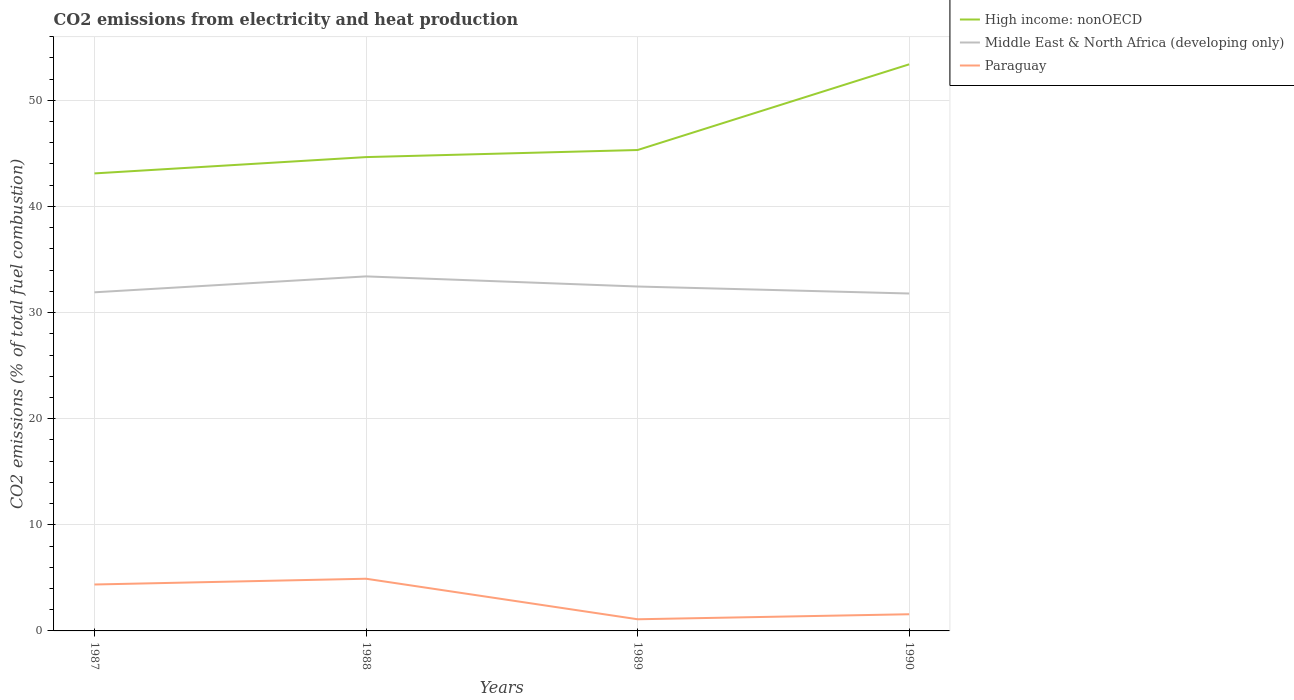How many different coloured lines are there?
Your response must be concise. 3. Across all years, what is the maximum amount of CO2 emitted in Paraguay?
Give a very brief answer. 1.1. What is the total amount of CO2 emitted in High income: nonOECD in the graph?
Your answer should be compact. -8.07. What is the difference between the highest and the second highest amount of CO2 emitted in Middle East & North Africa (developing only)?
Make the answer very short. 1.61. What is the difference between the highest and the lowest amount of CO2 emitted in Middle East & North Africa (developing only)?
Keep it short and to the point. 2. How many years are there in the graph?
Your answer should be very brief. 4. What is the difference between two consecutive major ticks on the Y-axis?
Offer a very short reply. 10. Does the graph contain any zero values?
Keep it short and to the point. No. Does the graph contain grids?
Make the answer very short. Yes. Where does the legend appear in the graph?
Ensure brevity in your answer.  Top right. What is the title of the graph?
Make the answer very short. CO2 emissions from electricity and heat production. What is the label or title of the Y-axis?
Ensure brevity in your answer.  CO2 emissions (% of total fuel combustion). What is the CO2 emissions (% of total fuel combustion) in High income: nonOECD in 1987?
Provide a succinct answer. 43.11. What is the CO2 emissions (% of total fuel combustion) in Middle East & North Africa (developing only) in 1987?
Ensure brevity in your answer.  31.91. What is the CO2 emissions (% of total fuel combustion) in Paraguay in 1987?
Offer a terse response. 4.38. What is the CO2 emissions (% of total fuel combustion) in High income: nonOECD in 1988?
Provide a short and direct response. 44.65. What is the CO2 emissions (% of total fuel combustion) in Middle East & North Africa (developing only) in 1988?
Keep it short and to the point. 33.41. What is the CO2 emissions (% of total fuel combustion) of Paraguay in 1988?
Your answer should be compact. 4.92. What is the CO2 emissions (% of total fuel combustion) in High income: nonOECD in 1989?
Your response must be concise. 45.32. What is the CO2 emissions (% of total fuel combustion) in Middle East & North Africa (developing only) in 1989?
Make the answer very short. 32.45. What is the CO2 emissions (% of total fuel combustion) in Paraguay in 1989?
Your response must be concise. 1.1. What is the CO2 emissions (% of total fuel combustion) of High income: nonOECD in 1990?
Give a very brief answer. 53.39. What is the CO2 emissions (% of total fuel combustion) in Middle East & North Africa (developing only) in 1990?
Your response must be concise. 31.8. What is the CO2 emissions (% of total fuel combustion) of Paraguay in 1990?
Provide a succinct answer. 1.57. Across all years, what is the maximum CO2 emissions (% of total fuel combustion) in High income: nonOECD?
Your answer should be compact. 53.39. Across all years, what is the maximum CO2 emissions (% of total fuel combustion) of Middle East & North Africa (developing only)?
Keep it short and to the point. 33.41. Across all years, what is the maximum CO2 emissions (% of total fuel combustion) in Paraguay?
Provide a short and direct response. 4.92. Across all years, what is the minimum CO2 emissions (% of total fuel combustion) in High income: nonOECD?
Provide a succinct answer. 43.11. Across all years, what is the minimum CO2 emissions (% of total fuel combustion) of Middle East & North Africa (developing only)?
Give a very brief answer. 31.8. Across all years, what is the minimum CO2 emissions (% of total fuel combustion) in Paraguay?
Offer a very short reply. 1.1. What is the total CO2 emissions (% of total fuel combustion) of High income: nonOECD in the graph?
Give a very brief answer. 186.47. What is the total CO2 emissions (% of total fuel combustion) of Middle East & North Africa (developing only) in the graph?
Make the answer very short. 129.57. What is the total CO2 emissions (% of total fuel combustion) in Paraguay in the graph?
Give a very brief answer. 11.96. What is the difference between the CO2 emissions (% of total fuel combustion) of High income: nonOECD in 1987 and that in 1988?
Keep it short and to the point. -1.54. What is the difference between the CO2 emissions (% of total fuel combustion) of Middle East & North Africa (developing only) in 1987 and that in 1988?
Your answer should be compact. -1.5. What is the difference between the CO2 emissions (% of total fuel combustion) of Paraguay in 1987 and that in 1988?
Your response must be concise. -0.54. What is the difference between the CO2 emissions (% of total fuel combustion) of High income: nonOECD in 1987 and that in 1989?
Ensure brevity in your answer.  -2.2. What is the difference between the CO2 emissions (% of total fuel combustion) of Middle East & North Africa (developing only) in 1987 and that in 1989?
Your response must be concise. -0.55. What is the difference between the CO2 emissions (% of total fuel combustion) in Paraguay in 1987 and that in 1989?
Keep it short and to the point. 3.28. What is the difference between the CO2 emissions (% of total fuel combustion) in High income: nonOECD in 1987 and that in 1990?
Give a very brief answer. -10.28. What is the difference between the CO2 emissions (% of total fuel combustion) in Middle East & North Africa (developing only) in 1987 and that in 1990?
Give a very brief answer. 0.11. What is the difference between the CO2 emissions (% of total fuel combustion) in Paraguay in 1987 and that in 1990?
Ensure brevity in your answer.  2.8. What is the difference between the CO2 emissions (% of total fuel combustion) in High income: nonOECD in 1988 and that in 1989?
Make the answer very short. -0.67. What is the difference between the CO2 emissions (% of total fuel combustion) of Middle East & North Africa (developing only) in 1988 and that in 1989?
Your answer should be very brief. 0.95. What is the difference between the CO2 emissions (% of total fuel combustion) of Paraguay in 1988 and that in 1989?
Keep it short and to the point. 3.82. What is the difference between the CO2 emissions (% of total fuel combustion) of High income: nonOECD in 1988 and that in 1990?
Your response must be concise. -8.74. What is the difference between the CO2 emissions (% of total fuel combustion) in Middle East & North Africa (developing only) in 1988 and that in 1990?
Your answer should be very brief. 1.61. What is the difference between the CO2 emissions (% of total fuel combustion) of Paraguay in 1988 and that in 1990?
Provide a short and direct response. 3.35. What is the difference between the CO2 emissions (% of total fuel combustion) of High income: nonOECD in 1989 and that in 1990?
Your response must be concise. -8.07. What is the difference between the CO2 emissions (% of total fuel combustion) of Middle East & North Africa (developing only) in 1989 and that in 1990?
Give a very brief answer. 0.66. What is the difference between the CO2 emissions (% of total fuel combustion) of Paraguay in 1989 and that in 1990?
Keep it short and to the point. -0.47. What is the difference between the CO2 emissions (% of total fuel combustion) of High income: nonOECD in 1987 and the CO2 emissions (% of total fuel combustion) of Middle East & North Africa (developing only) in 1988?
Provide a succinct answer. 9.71. What is the difference between the CO2 emissions (% of total fuel combustion) in High income: nonOECD in 1987 and the CO2 emissions (% of total fuel combustion) in Paraguay in 1988?
Make the answer very short. 38.2. What is the difference between the CO2 emissions (% of total fuel combustion) of Middle East & North Africa (developing only) in 1987 and the CO2 emissions (% of total fuel combustion) of Paraguay in 1988?
Offer a terse response. 26.99. What is the difference between the CO2 emissions (% of total fuel combustion) of High income: nonOECD in 1987 and the CO2 emissions (% of total fuel combustion) of Middle East & North Africa (developing only) in 1989?
Offer a terse response. 10.66. What is the difference between the CO2 emissions (% of total fuel combustion) of High income: nonOECD in 1987 and the CO2 emissions (% of total fuel combustion) of Paraguay in 1989?
Keep it short and to the point. 42.01. What is the difference between the CO2 emissions (% of total fuel combustion) of Middle East & North Africa (developing only) in 1987 and the CO2 emissions (% of total fuel combustion) of Paraguay in 1989?
Provide a succinct answer. 30.81. What is the difference between the CO2 emissions (% of total fuel combustion) in High income: nonOECD in 1987 and the CO2 emissions (% of total fuel combustion) in Middle East & North Africa (developing only) in 1990?
Keep it short and to the point. 11.32. What is the difference between the CO2 emissions (% of total fuel combustion) in High income: nonOECD in 1987 and the CO2 emissions (% of total fuel combustion) in Paraguay in 1990?
Your answer should be compact. 41.54. What is the difference between the CO2 emissions (% of total fuel combustion) in Middle East & North Africa (developing only) in 1987 and the CO2 emissions (% of total fuel combustion) in Paraguay in 1990?
Ensure brevity in your answer.  30.34. What is the difference between the CO2 emissions (% of total fuel combustion) of High income: nonOECD in 1988 and the CO2 emissions (% of total fuel combustion) of Middle East & North Africa (developing only) in 1989?
Offer a very short reply. 12.2. What is the difference between the CO2 emissions (% of total fuel combustion) of High income: nonOECD in 1988 and the CO2 emissions (% of total fuel combustion) of Paraguay in 1989?
Ensure brevity in your answer.  43.55. What is the difference between the CO2 emissions (% of total fuel combustion) in Middle East & North Africa (developing only) in 1988 and the CO2 emissions (% of total fuel combustion) in Paraguay in 1989?
Keep it short and to the point. 32.31. What is the difference between the CO2 emissions (% of total fuel combustion) of High income: nonOECD in 1988 and the CO2 emissions (% of total fuel combustion) of Middle East & North Africa (developing only) in 1990?
Offer a terse response. 12.85. What is the difference between the CO2 emissions (% of total fuel combustion) in High income: nonOECD in 1988 and the CO2 emissions (% of total fuel combustion) in Paraguay in 1990?
Ensure brevity in your answer.  43.08. What is the difference between the CO2 emissions (% of total fuel combustion) in Middle East & North Africa (developing only) in 1988 and the CO2 emissions (% of total fuel combustion) in Paraguay in 1990?
Your response must be concise. 31.84. What is the difference between the CO2 emissions (% of total fuel combustion) in High income: nonOECD in 1989 and the CO2 emissions (% of total fuel combustion) in Middle East & North Africa (developing only) in 1990?
Make the answer very short. 13.52. What is the difference between the CO2 emissions (% of total fuel combustion) of High income: nonOECD in 1989 and the CO2 emissions (% of total fuel combustion) of Paraguay in 1990?
Your response must be concise. 43.75. What is the difference between the CO2 emissions (% of total fuel combustion) of Middle East & North Africa (developing only) in 1989 and the CO2 emissions (% of total fuel combustion) of Paraguay in 1990?
Give a very brief answer. 30.88. What is the average CO2 emissions (% of total fuel combustion) in High income: nonOECD per year?
Keep it short and to the point. 46.62. What is the average CO2 emissions (% of total fuel combustion) of Middle East & North Africa (developing only) per year?
Provide a succinct answer. 32.39. What is the average CO2 emissions (% of total fuel combustion) of Paraguay per year?
Provide a short and direct response. 2.99. In the year 1987, what is the difference between the CO2 emissions (% of total fuel combustion) in High income: nonOECD and CO2 emissions (% of total fuel combustion) in Middle East & North Africa (developing only)?
Offer a terse response. 11.2. In the year 1987, what is the difference between the CO2 emissions (% of total fuel combustion) of High income: nonOECD and CO2 emissions (% of total fuel combustion) of Paraguay?
Provide a short and direct response. 38.74. In the year 1987, what is the difference between the CO2 emissions (% of total fuel combustion) of Middle East & North Africa (developing only) and CO2 emissions (% of total fuel combustion) of Paraguay?
Provide a short and direct response. 27.53. In the year 1988, what is the difference between the CO2 emissions (% of total fuel combustion) of High income: nonOECD and CO2 emissions (% of total fuel combustion) of Middle East & North Africa (developing only)?
Provide a short and direct response. 11.24. In the year 1988, what is the difference between the CO2 emissions (% of total fuel combustion) in High income: nonOECD and CO2 emissions (% of total fuel combustion) in Paraguay?
Keep it short and to the point. 39.73. In the year 1988, what is the difference between the CO2 emissions (% of total fuel combustion) in Middle East & North Africa (developing only) and CO2 emissions (% of total fuel combustion) in Paraguay?
Provide a short and direct response. 28.49. In the year 1989, what is the difference between the CO2 emissions (% of total fuel combustion) of High income: nonOECD and CO2 emissions (% of total fuel combustion) of Middle East & North Africa (developing only)?
Your answer should be compact. 12.86. In the year 1989, what is the difference between the CO2 emissions (% of total fuel combustion) in High income: nonOECD and CO2 emissions (% of total fuel combustion) in Paraguay?
Offer a very short reply. 44.22. In the year 1989, what is the difference between the CO2 emissions (% of total fuel combustion) of Middle East & North Africa (developing only) and CO2 emissions (% of total fuel combustion) of Paraguay?
Your answer should be compact. 31.36. In the year 1990, what is the difference between the CO2 emissions (% of total fuel combustion) in High income: nonOECD and CO2 emissions (% of total fuel combustion) in Middle East & North Africa (developing only)?
Make the answer very short. 21.6. In the year 1990, what is the difference between the CO2 emissions (% of total fuel combustion) in High income: nonOECD and CO2 emissions (% of total fuel combustion) in Paraguay?
Ensure brevity in your answer.  51.82. In the year 1990, what is the difference between the CO2 emissions (% of total fuel combustion) of Middle East & North Africa (developing only) and CO2 emissions (% of total fuel combustion) of Paraguay?
Offer a very short reply. 30.23. What is the ratio of the CO2 emissions (% of total fuel combustion) of High income: nonOECD in 1987 to that in 1988?
Provide a short and direct response. 0.97. What is the ratio of the CO2 emissions (% of total fuel combustion) of Middle East & North Africa (developing only) in 1987 to that in 1988?
Your answer should be compact. 0.96. What is the ratio of the CO2 emissions (% of total fuel combustion) in Paraguay in 1987 to that in 1988?
Offer a very short reply. 0.89. What is the ratio of the CO2 emissions (% of total fuel combustion) in High income: nonOECD in 1987 to that in 1989?
Your answer should be compact. 0.95. What is the ratio of the CO2 emissions (% of total fuel combustion) of Middle East & North Africa (developing only) in 1987 to that in 1989?
Make the answer very short. 0.98. What is the ratio of the CO2 emissions (% of total fuel combustion) in Paraguay in 1987 to that in 1989?
Give a very brief answer. 3.98. What is the ratio of the CO2 emissions (% of total fuel combustion) of High income: nonOECD in 1987 to that in 1990?
Your answer should be very brief. 0.81. What is the ratio of the CO2 emissions (% of total fuel combustion) of Middle East & North Africa (developing only) in 1987 to that in 1990?
Keep it short and to the point. 1. What is the ratio of the CO2 emissions (% of total fuel combustion) in Paraguay in 1987 to that in 1990?
Provide a short and direct response. 2.79. What is the ratio of the CO2 emissions (% of total fuel combustion) of Middle East & North Africa (developing only) in 1988 to that in 1989?
Your response must be concise. 1.03. What is the ratio of the CO2 emissions (% of total fuel combustion) of Paraguay in 1988 to that in 1989?
Your answer should be very brief. 4.48. What is the ratio of the CO2 emissions (% of total fuel combustion) of High income: nonOECD in 1988 to that in 1990?
Your answer should be very brief. 0.84. What is the ratio of the CO2 emissions (% of total fuel combustion) in Middle East & North Africa (developing only) in 1988 to that in 1990?
Your answer should be compact. 1.05. What is the ratio of the CO2 emissions (% of total fuel combustion) in Paraguay in 1988 to that in 1990?
Your answer should be compact. 3.13. What is the ratio of the CO2 emissions (% of total fuel combustion) of High income: nonOECD in 1989 to that in 1990?
Provide a short and direct response. 0.85. What is the ratio of the CO2 emissions (% of total fuel combustion) in Middle East & North Africa (developing only) in 1989 to that in 1990?
Provide a short and direct response. 1.02. What is the ratio of the CO2 emissions (% of total fuel combustion) of Paraguay in 1989 to that in 1990?
Your response must be concise. 0.7. What is the difference between the highest and the second highest CO2 emissions (% of total fuel combustion) in High income: nonOECD?
Ensure brevity in your answer.  8.07. What is the difference between the highest and the second highest CO2 emissions (% of total fuel combustion) of Middle East & North Africa (developing only)?
Your answer should be compact. 0.95. What is the difference between the highest and the second highest CO2 emissions (% of total fuel combustion) in Paraguay?
Offer a very short reply. 0.54. What is the difference between the highest and the lowest CO2 emissions (% of total fuel combustion) of High income: nonOECD?
Give a very brief answer. 10.28. What is the difference between the highest and the lowest CO2 emissions (% of total fuel combustion) of Middle East & North Africa (developing only)?
Your answer should be compact. 1.61. What is the difference between the highest and the lowest CO2 emissions (% of total fuel combustion) of Paraguay?
Give a very brief answer. 3.82. 